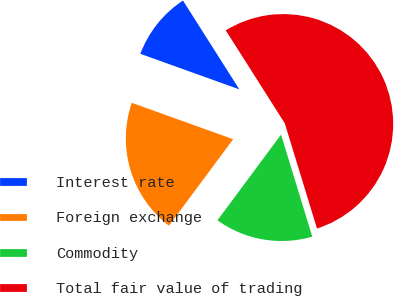<chart> <loc_0><loc_0><loc_500><loc_500><pie_chart><fcel>Interest rate<fcel>Foreign exchange<fcel>Commodity<fcel>Total fair value of trading<nl><fcel>10.51%<fcel>20.33%<fcel>14.89%<fcel>54.28%<nl></chart> 